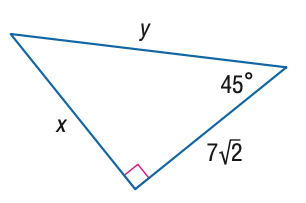Question: Find x.
Choices:
A. 7
B. 7 \sqrt { 2 }
C. 14
D. 7 \sqrt { 6 }
Answer with the letter. Answer: B 